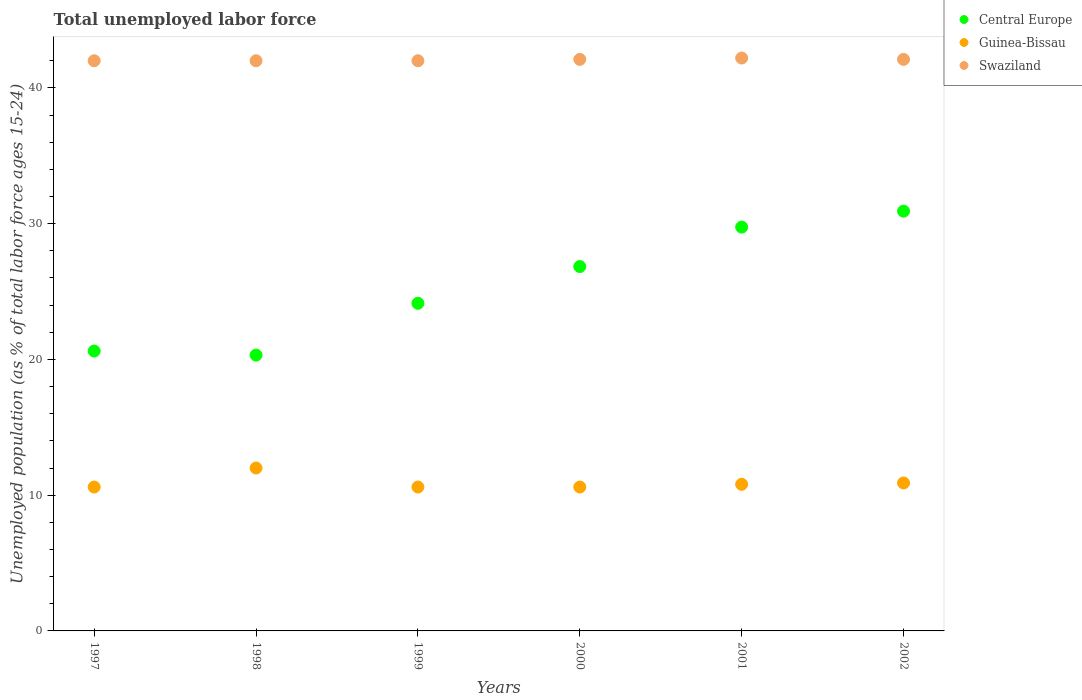How many different coloured dotlines are there?
Your response must be concise. 3. Is the number of dotlines equal to the number of legend labels?
Offer a terse response. Yes. What is the percentage of unemployed population in in Central Europe in 1997?
Provide a succinct answer. 20.62. Across all years, what is the maximum percentage of unemployed population in in Swaziland?
Keep it short and to the point. 42.2. Across all years, what is the minimum percentage of unemployed population in in Guinea-Bissau?
Ensure brevity in your answer.  10.6. In which year was the percentage of unemployed population in in Guinea-Bissau maximum?
Offer a very short reply. 1998. What is the total percentage of unemployed population in in Swaziland in the graph?
Offer a terse response. 252.4. What is the difference between the percentage of unemployed population in in Guinea-Bissau in 1997 and that in 2002?
Your answer should be compact. -0.3. What is the difference between the percentage of unemployed population in in Swaziland in 1998 and the percentage of unemployed population in in Central Europe in 1997?
Provide a short and direct response. 21.38. What is the average percentage of unemployed population in in Swaziland per year?
Offer a terse response. 42.07. In the year 2001, what is the difference between the percentage of unemployed population in in Central Europe and percentage of unemployed population in in Guinea-Bissau?
Your answer should be compact. 18.95. In how many years, is the percentage of unemployed population in in Swaziland greater than 28 %?
Your response must be concise. 6. What is the ratio of the percentage of unemployed population in in Central Europe in 2000 to that in 2001?
Keep it short and to the point. 0.9. Is the percentage of unemployed population in in Central Europe in 1998 less than that in 2002?
Offer a very short reply. Yes. Is the difference between the percentage of unemployed population in in Central Europe in 2001 and 2002 greater than the difference between the percentage of unemployed population in in Guinea-Bissau in 2001 and 2002?
Your answer should be compact. No. What is the difference between the highest and the second highest percentage of unemployed population in in Guinea-Bissau?
Your answer should be very brief. 1.1. What is the difference between the highest and the lowest percentage of unemployed population in in Central Europe?
Make the answer very short. 10.61. Is it the case that in every year, the sum of the percentage of unemployed population in in Swaziland and percentage of unemployed population in in Guinea-Bissau  is greater than the percentage of unemployed population in in Central Europe?
Your answer should be compact. Yes. Does the percentage of unemployed population in in Swaziland monotonically increase over the years?
Your response must be concise. No. Is the percentage of unemployed population in in Swaziland strictly less than the percentage of unemployed population in in Central Europe over the years?
Your answer should be compact. No. How many years are there in the graph?
Make the answer very short. 6. What is the difference between two consecutive major ticks on the Y-axis?
Provide a short and direct response. 10. Does the graph contain any zero values?
Your answer should be very brief. No. What is the title of the graph?
Your response must be concise. Total unemployed labor force. Does "Faeroe Islands" appear as one of the legend labels in the graph?
Your answer should be very brief. No. What is the label or title of the X-axis?
Ensure brevity in your answer.  Years. What is the label or title of the Y-axis?
Make the answer very short. Unemployed population (as % of total labor force ages 15-24). What is the Unemployed population (as % of total labor force ages 15-24) in Central Europe in 1997?
Give a very brief answer. 20.62. What is the Unemployed population (as % of total labor force ages 15-24) in Guinea-Bissau in 1997?
Ensure brevity in your answer.  10.6. What is the Unemployed population (as % of total labor force ages 15-24) in Swaziland in 1997?
Your answer should be very brief. 42. What is the Unemployed population (as % of total labor force ages 15-24) of Central Europe in 1998?
Give a very brief answer. 20.32. What is the Unemployed population (as % of total labor force ages 15-24) of Guinea-Bissau in 1998?
Keep it short and to the point. 12. What is the Unemployed population (as % of total labor force ages 15-24) in Central Europe in 1999?
Your response must be concise. 24.13. What is the Unemployed population (as % of total labor force ages 15-24) in Guinea-Bissau in 1999?
Your answer should be very brief. 10.6. What is the Unemployed population (as % of total labor force ages 15-24) in Swaziland in 1999?
Keep it short and to the point. 42. What is the Unemployed population (as % of total labor force ages 15-24) of Central Europe in 2000?
Make the answer very short. 26.84. What is the Unemployed population (as % of total labor force ages 15-24) in Guinea-Bissau in 2000?
Offer a terse response. 10.6. What is the Unemployed population (as % of total labor force ages 15-24) of Swaziland in 2000?
Your response must be concise. 42.1. What is the Unemployed population (as % of total labor force ages 15-24) in Central Europe in 2001?
Keep it short and to the point. 29.75. What is the Unemployed population (as % of total labor force ages 15-24) in Guinea-Bissau in 2001?
Offer a terse response. 10.8. What is the Unemployed population (as % of total labor force ages 15-24) of Swaziland in 2001?
Offer a very short reply. 42.2. What is the Unemployed population (as % of total labor force ages 15-24) of Central Europe in 2002?
Offer a terse response. 30.92. What is the Unemployed population (as % of total labor force ages 15-24) of Guinea-Bissau in 2002?
Keep it short and to the point. 10.9. What is the Unemployed population (as % of total labor force ages 15-24) of Swaziland in 2002?
Provide a succinct answer. 42.1. Across all years, what is the maximum Unemployed population (as % of total labor force ages 15-24) of Central Europe?
Provide a succinct answer. 30.92. Across all years, what is the maximum Unemployed population (as % of total labor force ages 15-24) of Guinea-Bissau?
Your response must be concise. 12. Across all years, what is the maximum Unemployed population (as % of total labor force ages 15-24) in Swaziland?
Keep it short and to the point. 42.2. Across all years, what is the minimum Unemployed population (as % of total labor force ages 15-24) of Central Europe?
Your answer should be compact. 20.32. Across all years, what is the minimum Unemployed population (as % of total labor force ages 15-24) in Guinea-Bissau?
Your answer should be compact. 10.6. Across all years, what is the minimum Unemployed population (as % of total labor force ages 15-24) in Swaziland?
Ensure brevity in your answer.  42. What is the total Unemployed population (as % of total labor force ages 15-24) in Central Europe in the graph?
Your answer should be compact. 152.57. What is the total Unemployed population (as % of total labor force ages 15-24) of Guinea-Bissau in the graph?
Offer a terse response. 65.5. What is the total Unemployed population (as % of total labor force ages 15-24) in Swaziland in the graph?
Provide a succinct answer. 252.4. What is the difference between the Unemployed population (as % of total labor force ages 15-24) of Central Europe in 1997 and that in 1998?
Ensure brevity in your answer.  0.3. What is the difference between the Unemployed population (as % of total labor force ages 15-24) of Guinea-Bissau in 1997 and that in 1998?
Your answer should be very brief. -1.4. What is the difference between the Unemployed population (as % of total labor force ages 15-24) in Swaziland in 1997 and that in 1998?
Your answer should be very brief. 0. What is the difference between the Unemployed population (as % of total labor force ages 15-24) in Central Europe in 1997 and that in 1999?
Offer a terse response. -3.52. What is the difference between the Unemployed population (as % of total labor force ages 15-24) of Guinea-Bissau in 1997 and that in 1999?
Offer a terse response. 0. What is the difference between the Unemployed population (as % of total labor force ages 15-24) in Swaziland in 1997 and that in 1999?
Your answer should be compact. 0. What is the difference between the Unemployed population (as % of total labor force ages 15-24) in Central Europe in 1997 and that in 2000?
Provide a succinct answer. -6.22. What is the difference between the Unemployed population (as % of total labor force ages 15-24) of Central Europe in 1997 and that in 2001?
Give a very brief answer. -9.13. What is the difference between the Unemployed population (as % of total labor force ages 15-24) in Swaziland in 1997 and that in 2001?
Provide a short and direct response. -0.2. What is the difference between the Unemployed population (as % of total labor force ages 15-24) of Central Europe in 1997 and that in 2002?
Provide a succinct answer. -10.3. What is the difference between the Unemployed population (as % of total labor force ages 15-24) in Guinea-Bissau in 1997 and that in 2002?
Provide a short and direct response. -0.3. What is the difference between the Unemployed population (as % of total labor force ages 15-24) in Swaziland in 1997 and that in 2002?
Offer a terse response. -0.1. What is the difference between the Unemployed population (as % of total labor force ages 15-24) of Central Europe in 1998 and that in 1999?
Your answer should be compact. -3.82. What is the difference between the Unemployed population (as % of total labor force ages 15-24) in Central Europe in 1998 and that in 2000?
Provide a succinct answer. -6.52. What is the difference between the Unemployed population (as % of total labor force ages 15-24) in Swaziland in 1998 and that in 2000?
Provide a short and direct response. -0.1. What is the difference between the Unemployed population (as % of total labor force ages 15-24) of Central Europe in 1998 and that in 2001?
Your answer should be very brief. -9.43. What is the difference between the Unemployed population (as % of total labor force ages 15-24) in Swaziland in 1998 and that in 2001?
Provide a succinct answer. -0.2. What is the difference between the Unemployed population (as % of total labor force ages 15-24) of Central Europe in 1998 and that in 2002?
Ensure brevity in your answer.  -10.61. What is the difference between the Unemployed population (as % of total labor force ages 15-24) in Guinea-Bissau in 1998 and that in 2002?
Keep it short and to the point. 1.1. What is the difference between the Unemployed population (as % of total labor force ages 15-24) in Central Europe in 1999 and that in 2000?
Offer a terse response. -2.71. What is the difference between the Unemployed population (as % of total labor force ages 15-24) in Guinea-Bissau in 1999 and that in 2000?
Provide a succinct answer. 0. What is the difference between the Unemployed population (as % of total labor force ages 15-24) in Central Europe in 1999 and that in 2001?
Give a very brief answer. -5.61. What is the difference between the Unemployed population (as % of total labor force ages 15-24) of Guinea-Bissau in 1999 and that in 2001?
Your response must be concise. -0.2. What is the difference between the Unemployed population (as % of total labor force ages 15-24) in Central Europe in 1999 and that in 2002?
Your response must be concise. -6.79. What is the difference between the Unemployed population (as % of total labor force ages 15-24) in Guinea-Bissau in 1999 and that in 2002?
Your answer should be compact. -0.3. What is the difference between the Unemployed population (as % of total labor force ages 15-24) in Central Europe in 2000 and that in 2001?
Your answer should be very brief. -2.91. What is the difference between the Unemployed population (as % of total labor force ages 15-24) of Guinea-Bissau in 2000 and that in 2001?
Provide a short and direct response. -0.2. What is the difference between the Unemployed population (as % of total labor force ages 15-24) in Swaziland in 2000 and that in 2001?
Offer a very short reply. -0.1. What is the difference between the Unemployed population (as % of total labor force ages 15-24) of Central Europe in 2000 and that in 2002?
Provide a succinct answer. -4.08. What is the difference between the Unemployed population (as % of total labor force ages 15-24) in Central Europe in 2001 and that in 2002?
Give a very brief answer. -1.18. What is the difference between the Unemployed population (as % of total labor force ages 15-24) in Swaziland in 2001 and that in 2002?
Provide a short and direct response. 0.1. What is the difference between the Unemployed population (as % of total labor force ages 15-24) in Central Europe in 1997 and the Unemployed population (as % of total labor force ages 15-24) in Guinea-Bissau in 1998?
Keep it short and to the point. 8.62. What is the difference between the Unemployed population (as % of total labor force ages 15-24) in Central Europe in 1997 and the Unemployed population (as % of total labor force ages 15-24) in Swaziland in 1998?
Give a very brief answer. -21.38. What is the difference between the Unemployed population (as % of total labor force ages 15-24) in Guinea-Bissau in 1997 and the Unemployed population (as % of total labor force ages 15-24) in Swaziland in 1998?
Offer a very short reply. -31.4. What is the difference between the Unemployed population (as % of total labor force ages 15-24) in Central Europe in 1997 and the Unemployed population (as % of total labor force ages 15-24) in Guinea-Bissau in 1999?
Your answer should be very brief. 10.02. What is the difference between the Unemployed population (as % of total labor force ages 15-24) in Central Europe in 1997 and the Unemployed population (as % of total labor force ages 15-24) in Swaziland in 1999?
Your response must be concise. -21.38. What is the difference between the Unemployed population (as % of total labor force ages 15-24) in Guinea-Bissau in 1997 and the Unemployed population (as % of total labor force ages 15-24) in Swaziland in 1999?
Your answer should be compact. -31.4. What is the difference between the Unemployed population (as % of total labor force ages 15-24) of Central Europe in 1997 and the Unemployed population (as % of total labor force ages 15-24) of Guinea-Bissau in 2000?
Offer a terse response. 10.02. What is the difference between the Unemployed population (as % of total labor force ages 15-24) in Central Europe in 1997 and the Unemployed population (as % of total labor force ages 15-24) in Swaziland in 2000?
Your response must be concise. -21.48. What is the difference between the Unemployed population (as % of total labor force ages 15-24) in Guinea-Bissau in 1997 and the Unemployed population (as % of total labor force ages 15-24) in Swaziland in 2000?
Give a very brief answer. -31.5. What is the difference between the Unemployed population (as % of total labor force ages 15-24) of Central Europe in 1997 and the Unemployed population (as % of total labor force ages 15-24) of Guinea-Bissau in 2001?
Your response must be concise. 9.82. What is the difference between the Unemployed population (as % of total labor force ages 15-24) of Central Europe in 1997 and the Unemployed population (as % of total labor force ages 15-24) of Swaziland in 2001?
Offer a terse response. -21.58. What is the difference between the Unemployed population (as % of total labor force ages 15-24) in Guinea-Bissau in 1997 and the Unemployed population (as % of total labor force ages 15-24) in Swaziland in 2001?
Ensure brevity in your answer.  -31.6. What is the difference between the Unemployed population (as % of total labor force ages 15-24) in Central Europe in 1997 and the Unemployed population (as % of total labor force ages 15-24) in Guinea-Bissau in 2002?
Provide a short and direct response. 9.72. What is the difference between the Unemployed population (as % of total labor force ages 15-24) of Central Europe in 1997 and the Unemployed population (as % of total labor force ages 15-24) of Swaziland in 2002?
Your answer should be compact. -21.48. What is the difference between the Unemployed population (as % of total labor force ages 15-24) of Guinea-Bissau in 1997 and the Unemployed population (as % of total labor force ages 15-24) of Swaziland in 2002?
Ensure brevity in your answer.  -31.5. What is the difference between the Unemployed population (as % of total labor force ages 15-24) in Central Europe in 1998 and the Unemployed population (as % of total labor force ages 15-24) in Guinea-Bissau in 1999?
Make the answer very short. 9.72. What is the difference between the Unemployed population (as % of total labor force ages 15-24) of Central Europe in 1998 and the Unemployed population (as % of total labor force ages 15-24) of Swaziland in 1999?
Your answer should be compact. -21.68. What is the difference between the Unemployed population (as % of total labor force ages 15-24) of Guinea-Bissau in 1998 and the Unemployed population (as % of total labor force ages 15-24) of Swaziland in 1999?
Provide a succinct answer. -30. What is the difference between the Unemployed population (as % of total labor force ages 15-24) in Central Europe in 1998 and the Unemployed population (as % of total labor force ages 15-24) in Guinea-Bissau in 2000?
Offer a terse response. 9.72. What is the difference between the Unemployed population (as % of total labor force ages 15-24) in Central Europe in 1998 and the Unemployed population (as % of total labor force ages 15-24) in Swaziland in 2000?
Your response must be concise. -21.78. What is the difference between the Unemployed population (as % of total labor force ages 15-24) in Guinea-Bissau in 1998 and the Unemployed population (as % of total labor force ages 15-24) in Swaziland in 2000?
Provide a succinct answer. -30.1. What is the difference between the Unemployed population (as % of total labor force ages 15-24) of Central Europe in 1998 and the Unemployed population (as % of total labor force ages 15-24) of Guinea-Bissau in 2001?
Your response must be concise. 9.52. What is the difference between the Unemployed population (as % of total labor force ages 15-24) of Central Europe in 1998 and the Unemployed population (as % of total labor force ages 15-24) of Swaziland in 2001?
Your response must be concise. -21.88. What is the difference between the Unemployed population (as % of total labor force ages 15-24) of Guinea-Bissau in 1998 and the Unemployed population (as % of total labor force ages 15-24) of Swaziland in 2001?
Ensure brevity in your answer.  -30.2. What is the difference between the Unemployed population (as % of total labor force ages 15-24) in Central Europe in 1998 and the Unemployed population (as % of total labor force ages 15-24) in Guinea-Bissau in 2002?
Your response must be concise. 9.42. What is the difference between the Unemployed population (as % of total labor force ages 15-24) of Central Europe in 1998 and the Unemployed population (as % of total labor force ages 15-24) of Swaziland in 2002?
Give a very brief answer. -21.78. What is the difference between the Unemployed population (as % of total labor force ages 15-24) in Guinea-Bissau in 1998 and the Unemployed population (as % of total labor force ages 15-24) in Swaziland in 2002?
Give a very brief answer. -30.1. What is the difference between the Unemployed population (as % of total labor force ages 15-24) of Central Europe in 1999 and the Unemployed population (as % of total labor force ages 15-24) of Guinea-Bissau in 2000?
Provide a succinct answer. 13.53. What is the difference between the Unemployed population (as % of total labor force ages 15-24) in Central Europe in 1999 and the Unemployed population (as % of total labor force ages 15-24) in Swaziland in 2000?
Provide a short and direct response. -17.97. What is the difference between the Unemployed population (as % of total labor force ages 15-24) in Guinea-Bissau in 1999 and the Unemployed population (as % of total labor force ages 15-24) in Swaziland in 2000?
Your response must be concise. -31.5. What is the difference between the Unemployed population (as % of total labor force ages 15-24) of Central Europe in 1999 and the Unemployed population (as % of total labor force ages 15-24) of Guinea-Bissau in 2001?
Offer a very short reply. 13.33. What is the difference between the Unemployed population (as % of total labor force ages 15-24) in Central Europe in 1999 and the Unemployed population (as % of total labor force ages 15-24) in Swaziland in 2001?
Your answer should be very brief. -18.07. What is the difference between the Unemployed population (as % of total labor force ages 15-24) in Guinea-Bissau in 1999 and the Unemployed population (as % of total labor force ages 15-24) in Swaziland in 2001?
Provide a short and direct response. -31.6. What is the difference between the Unemployed population (as % of total labor force ages 15-24) in Central Europe in 1999 and the Unemployed population (as % of total labor force ages 15-24) in Guinea-Bissau in 2002?
Give a very brief answer. 13.23. What is the difference between the Unemployed population (as % of total labor force ages 15-24) of Central Europe in 1999 and the Unemployed population (as % of total labor force ages 15-24) of Swaziland in 2002?
Your response must be concise. -17.97. What is the difference between the Unemployed population (as % of total labor force ages 15-24) of Guinea-Bissau in 1999 and the Unemployed population (as % of total labor force ages 15-24) of Swaziland in 2002?
Ensure brevity in your answer.  -31.5. What is the difference between the Unemployed population (as % of total labor force ages 15-24) in Central Europe in 2000 and the Unemployed population (as % of total labor force ages 15-24) in Guinea-Bissau in 2001?
Provide a short and direct response. 16.04. What is the difference between the Unemployed population (as % of total labor force ages 15-24) in Central Europe in 2000 and the Unemployed population (as % of total labor force ages 15-24) in Swaziland in 2001?
Offer a very short reply. -15.36. What is the difference between the Unemployed population (as % of total labor force ages 15-24) of Guinea-Bissau in 2000 and the Unemployed population (as % of total labor force ages 15-24) of Swaziland in 2001?
Keep it short and to the point. -31.6. What is the difference between the Unemployed population (as % of total labor force ages 15-24) in Central Europe in 2000 and the Unemployed population (as % of total labor force ages 15-24) in Guinea-Bissau in 2002?
Offer a very short reply. 15.94. What is the difference between the Unemployed population (as % of total labor force ages 15-24) in Central Europe in 2000 and the Unemployed population (as % of total labor force ages 15-24) in Swaziland in 2002?
Ensure brevity in your answer.  -15.26. What is the difference between the Unemployed population (as % of total labor force ages 15-24) of Guinea-Bissau in 2000 and the Unemployed population (as % of total labor force ages 15-24) of Swaziland in 2002?
Provide a short and direct response. -31.5. What is the difference between the Unemployed population (as % of total labor force ages 15-24) of Central Europe in 2001 and the Unemployed population (as % of total labor force ages 15-24) of Guinea-Bissau in 2002?
Provide a succinct answer. 18.85. What is the difference between the Unemployed population (as % of total labor force ages 15-24) of Central Europe in 2001 and the Unemployed population (as % of total labor force ages 15-24) of Swaziland in 2002?
Keep it short and to the point. -12.35. What is the difference between the Unemployed population (as % of total labor force ages 15-24) in Guinea-Bissau in 2001 and the Unemployed population (as % of total labor force ages 15-24) in Swaziland in 2002?
Provide a succinct answer. -31.3. What is the average Unemployed population (as % of total labor force ages 15-24) in Central Europe per year?
Provide a short and direct response. 25.43. What is the average Unemployed population (as % of total labor force ages 15-24) of Guinea-Bissau per year?
Provide a succinct answer. 10.92. What is the average Unemployed population (as % of total labor force ages 15-24) in Swaziland per year?
Keep it short and to the point. 42.07. In the year 1997, what is the difference between the Unemployed population (as % of total labor force ages 15-24) of Central Europe and Unemployed population (as % of total labor force ages 15-24) of Guinea-Bissau?
Your answer should be compact. 10.02. In the year 1997, what is the difference between the Unemployed population (as % of total labor force ages 15-24) in Central Europe and Unemployed population (as % of total labor force ages 15-24) in Swaziland?
Give a very brief answer. -21.38. In the year 1997, what is the difference between the Unemployed population (as % of total labor force ages 15-24) in Guinea-Bissau and Unemployed population (as % of total labor force ages 15-24) in Swaziland?
Your answer should be compact. -31.4. In the year 1998, what is the difference between the Unemployed population (as % of total labor force ages 15-24) of Central Europe and Unemployed population (as % of total labor force ages 15-24) of Guinea-Bissau?
Offer a terse response. 8.32. In the year 1998, what is the difference between the Unemployed population (as % of total labor force ages 15-24) of Central Europe and Unemployed population (as % of total labor force ages 15-24) of Swaziland?
Offer a terse response. -21.68. In the year 1999, what is the difference between the Unemployed population (as % of total labor force ages 15-24) of Central Europe and Unemployed population (as % of total labor force ages 15-24) of Guinea-Bissau?
Provide a short and direct response. 13.53. In the year 1999, what is the difference between the Unemployed population (as % of total labor force ages 15-24) in Central Europe and Unemployed population (as % of total labor force ages 15-24) in Swaziland?
Your answer should be very brief. -17.87. In the year 1999, what is the difference between the Unemployed population (as % of total labor force ages 15-24) of Guinea-Bissau and Unemployed population (as % of total labor force ages 15-24) of Swaziland?
Provide a short and direct response. -31.4. In the year 2000, what is the difference between the Unemployed population (as % of total labor force ages 15-24) in Central Europe and Unemployed population (as % of total labor force ages 15-24) in Guinea-Bissau?
Provide a short and direct response. 16.24. In the year 2000, what is the difference between the Unemployed population (as % of total labor force ages 15-24) in Central Europe and Unemployed population (as % of total labor force ages 15-24) in Swaziland?
Ensure brevity in your answer.  -15.26. In the year 2000, what is the difference between the Unemployed population (as % of total labor force ages 15-24) of Guinea-Bissau and Unemployed population (as % of total labor force ages 15-24) of Swaziland?
Offer a terse response. -31.5. In the year 2001, what is the difference between the Unemployed population (as % of total labor force ages 15-24) of Central Europe and Unemployed population (as % of total labor force ages 15-24) of Guinea-Bissau?
Provide a succinct answer. 18.95. In the year 2001, what is the difference between the Unemployed population (as % of total labor force ages 15-24) of Central Europe and Unemployed population (as % of total labor force ages 15-24) of Swaziland?
Offer a terse response. -12.45. In the year 2001, what is the difference between the Unemployed population (as % of total labor force ages 15-24) of Guinea-Bissau and Unemployed population (as % of total labor force ages 15-24) of Swaziland?
Provide a succinct answer. -31.4. In the year 2002, what is the difference between the Unemployed population (as % of total labor force ages 15-24) in Central Europe and Unemployed population (as % of total labor force ages 15-24) in Guinea-Bissau?
Provide a short and direct response. 20.02. In the year 2002, what is the difference between the Unemployed population (as % of total labor force ages 15-24) of Central Europe and Unemployed population (as % of total labor force ages 15-24) of Swaziland?
Give a very brief answer. -11.18. In the year 2002, what is the difference between the Unemployed population (as % of total labor force ages 15-24) of Guinea-Bissau and Unemployed population (as % of total labor force ages 15-24) of Swaziland?
Your answer should be very brief. -31.2. What is the ratio of the Unemployed population (as % of total labor force ages 15-24) of Central Europe in 1997 to that in 1998?
Give a very brief answer. 1.01. What is the ratio of the Unemployed population (as % of total labor force ages 15-24) in Guinea-Bissau in 1997 to that in 1998?
Provide a succinct answer. 0.88. What is the ratio of the Unemployed population (as % of total labor force ages 15-24) of Central Europe in 1997 to that in 1999?
Make the answer very short. 0.85. What is the ratio of the Unemployed population (as % of total labor force ages 15-24) in Central Europe in 1997 to that in 2000?
Offer a very short reply. 0.77. What is the ratio of the Unemployed population (as % of total labor force ages 15-24) of Guinea-Bissau in 1997 to that in 2000?
Offer a very short reply. 1. What is the ratio of the Unemployed population (as % of total labor force ages 15-24) of Central Europe in 1997 to that in 2001?
Give a very brief answer. 0.69. What is the ratio of the Unemployed population (as % of total labor force ages 15-24) in Guinea-Bissau in 1997 to that in 2001?
Provide a short and direct response. 0.98. What is the ratio of the Unemployed population (as % of total labor force ages 15-24) of Central Europe in 1997 to that in 2002?
Provide a succinct answer. 0.67. What is the ratio of the Unemployed population (as % of total labor force ages 15-24) of Guinea-Bissau in 1997 to that in 2002?
Your answer should be very brief. 0.97. What is the ratio of the Unemployed population (as % of total labor force ages 15-24) in Swaziland in 1997 to that in 2002?
Make the answer very short. 1. What is the ratio of the Unemployed population (as % of total labor force ages 15-24) in Central Europe in 1998 to that in 1999?
Offer a very short reply. 0.84. What is the ratio of the Unemployed population (as % of total labor force ages 15-24) of Guinea-Bissau in 1998 to that in 1999?
Make the answer very short. 1.13. What is the ratio of the Unemployed population (as % of total labor force ages 15-24) of Central Europe in 1998 to that in 2000?
Keep it short and to the point. 0.76. What is the ratio of the Unemployed population (as % of total labor force ages 15-24) of Guinea-Bissau in 1998 to that in 2000?
Your answer should be compact. 1.13. What is the ratio of the Unemployed population (as % of total labor force ages 15-24) in Central Europe in 1998 to that in 2001?
Your answer should be compact. 0.68. What is the ratio of the Unemployed population (as % of total labor force ages 15-24) in Central Europe in 1998 to that in 2002?
Provide a short and direct response. 0.66. What is the ratio of the Unemployed population (as % of total labor force ages 15-24) of Guinea-Bissau in 1998 to that in 2002?
Provide a short and direct response. 1.1. What is the ratio of the Unemployed population (as % of total labor force ages 15-24) in Swaziland in 1998 to that in 2002?
Provide a short and direct response. 1. What is the ratio of the Unemployed population (as % of total labor force ages 15-24) of Central Europe in 1999 to that in 2000?
Offer a very short reply. 0.9. What is the ratio of the Unemployed population (as % of total labor force ages 15-24) in Central Europe in 1999 to that in 2001?
Your answer should be compact. 0.81. What is the ratio of the Unemployed population (as % of total labor force ages 15-24) of Guinea-Bissau in 1999 to that in 2001?
Offer a very short reply. 0.98. What is the ratio of the Unemployed population (as % of total labor force ages 15-24) in Central Europe in 1999 to that in 2002?
Provide a short and direct response. 0.78. What is the ratio of the Unemployed population (as % of total labor force ages 15-24) of Guinea-Bissau in 1999 to that in 2002?
Ensure brevity in your answer.  0.97. What is the ratio of the Unemployed population (as % of total labor force ages 15-24) of Central Europe in 2000 to that in 2001?
Provide a short and direct response. 0.9. What is the ratio of the Unemployed population (as % of total labor force ages 15-24) in Guinea-Bissau in 2000 to that in 2001?
Your answer should be compact. 0.98. What is the ratio of the Unemployed population (as % of total labor force ages 15-24) of Central Europe in 2000 to that in 2002?
Make the answer very short. 0.87. What is the ratio of the Unemployed population (as % of total labor force ages 15-24) in Guinea-Bissau in 2000 to that in 2002?
Make the answer very short. 0.97. What is the ratio of the Unemployed population (as % of total labor force ages 15-24) of Swaziland in 2000 to that in 2002?
Your answer should be very brief. 1. What is the ratio of the Unemployed population (as % of total labor force ages 15-24) of Central Europe in 2001 to that in 2002?
Your answer should be compact. 0.96. What is the ratio of the Unemployed population (as % of total labor force ages 15-24) in Guinea-Bissau in 2001 to that in 2002?
Give a very brief answer. 0.99. What is the difference between the highest and the second highest Unemployed population (as % of total labor force ages 15-24) of Central Europe?
Your response must be concise. 1.18. What is the difference between the highest and the second highest Unemployed population (as % of total labor force ages 15-24) of Guinea-Bissau?
Your response must be concise. 1.1. What is the difference between the highest and the lowest Unemployed population (as % of total labor force ages 15-24) in Central Europe?
Keep it short and to the point. 10.61. What is the difference between the highest and the lowest Unemployed population (as % of total labor force ages 15-24) of Guinea-Bissau?
Keep it short and to the point. 1.4. 